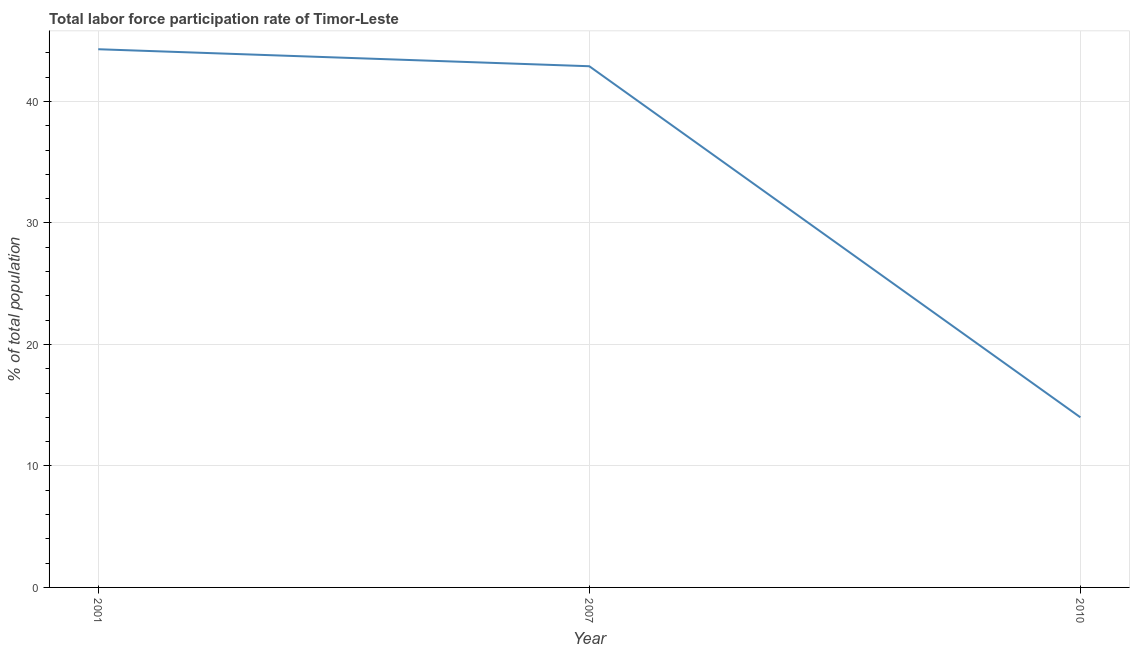What is the total labor force participation rate in 2010?
Ensure brevity in your answer.  14. Across all years, what is the maximum total labor force participation rate?
Your response must be concise. 44.3. In which year was the total labor force participation rate minimum?
Your response must be concise. 2010. What is the sum of the total labor force participation rate?
Your answer should be very brief. 101.2. What is the difference between the total labor force participation rate in 2007 and 2010?
Offer a very short reply. 28.9. What is the average total labor force participation rate per year?
Provide a succinct answer. 33.73. What is the median total labor force participation rate?
Provide a succinct answer. 42.9. Do a majority of the years between 2001 and 2007 (inclusive) have total labor force participation rate greater than 6 %?
Your answer should be very brief. Yes. What is the ratio of the total labor force participation rate in 2007 to that in 2010?
Ensure brevity in your answer.  3.06. Is the total labor force participation rate in 2001 less than that in 2010?
Your answer should be compact. No. Is the difference between the total labor force participation rate in 2001 and 2007 greater than the difference between any two years?
Provide a short and direct response. No. What is the difference between the highest and the second highest total labor force participation rate?
Offer a terse response. 1.4. What is the difference between the highest and the lowest total labor force participation rate?
Provide a short and direct response. 30.3. In how many years, is the total labor force participation rate greater than the average total labor force participation rate taken over all years?
Make the answer very short. 2. What is the difference between two consecutive major ticks on the Y-axis?
Ensure brevity in your answer.  10. Does the graph contain grids?
Your answer should be compact. Yes. What is the title of the graph?
Ensure brevity in your answer.  Total labor force participation rate of Timor-Leste. What is the label or title of the X-axis?
Your response must be concise. Year. What is the label or title of the Y-axis?
Your response must be concise. % of total population. What is the % of total population of 2001?
Your answer should be compact. 44.3. What is the % of total population in 2007?
Ensure brevity in your answer.  42.9. What is the % of total population in 2010?
Provide a short and direct response. 14. What is the difference between the % of total population in 2001 and 2007?
Make the answer very short. 1.4. What is the difference between the % of total population in 2001 and 2010?
Your answer should be very brief. 30.3. What is the difference between the % of total population in 2007 and 2010?
Provide a short and direct response. 28.9. What is the ratio of the % of total population in 2001 to that in 2007?
Provide a succinct answer. 1.03. What is the ratio of the % of total population in 2001 to that in 2010?
Provide a succinct answer. 3.16. What is the ratio of the % of total population in 2007 to that in 2010?
Offer a terse response. 3.06. 